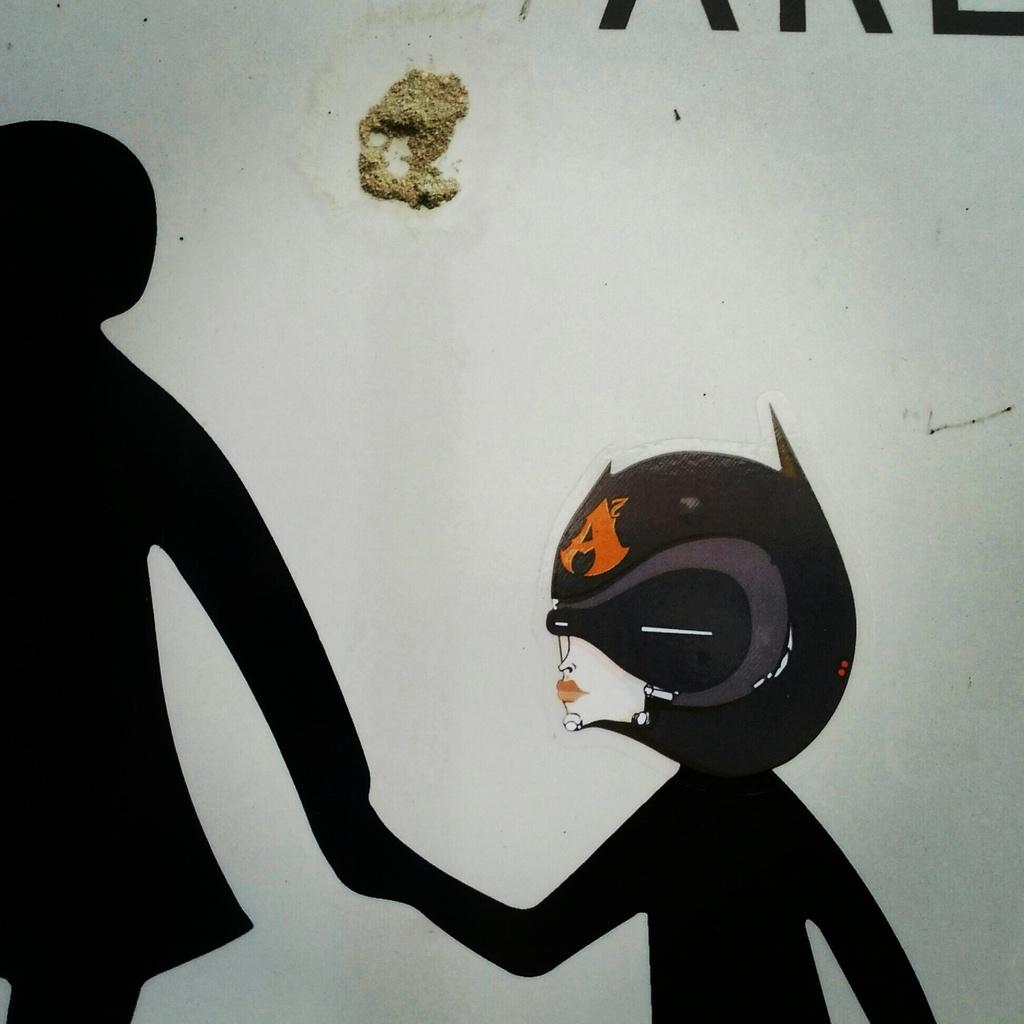What is on the wall in the foreground of the image? There is a sticker, a painting, and some text present on the wall in the foreground of the image. Can you describe the appearance of the wall in the foreground of the image? It appears that there is mud on the wall in the foreground of the image. Where is the record player located in the image? There is no record player present in the image. Can you see a crowd gathered near the seashore in the image? There is no seashore or crowd present in the image. 